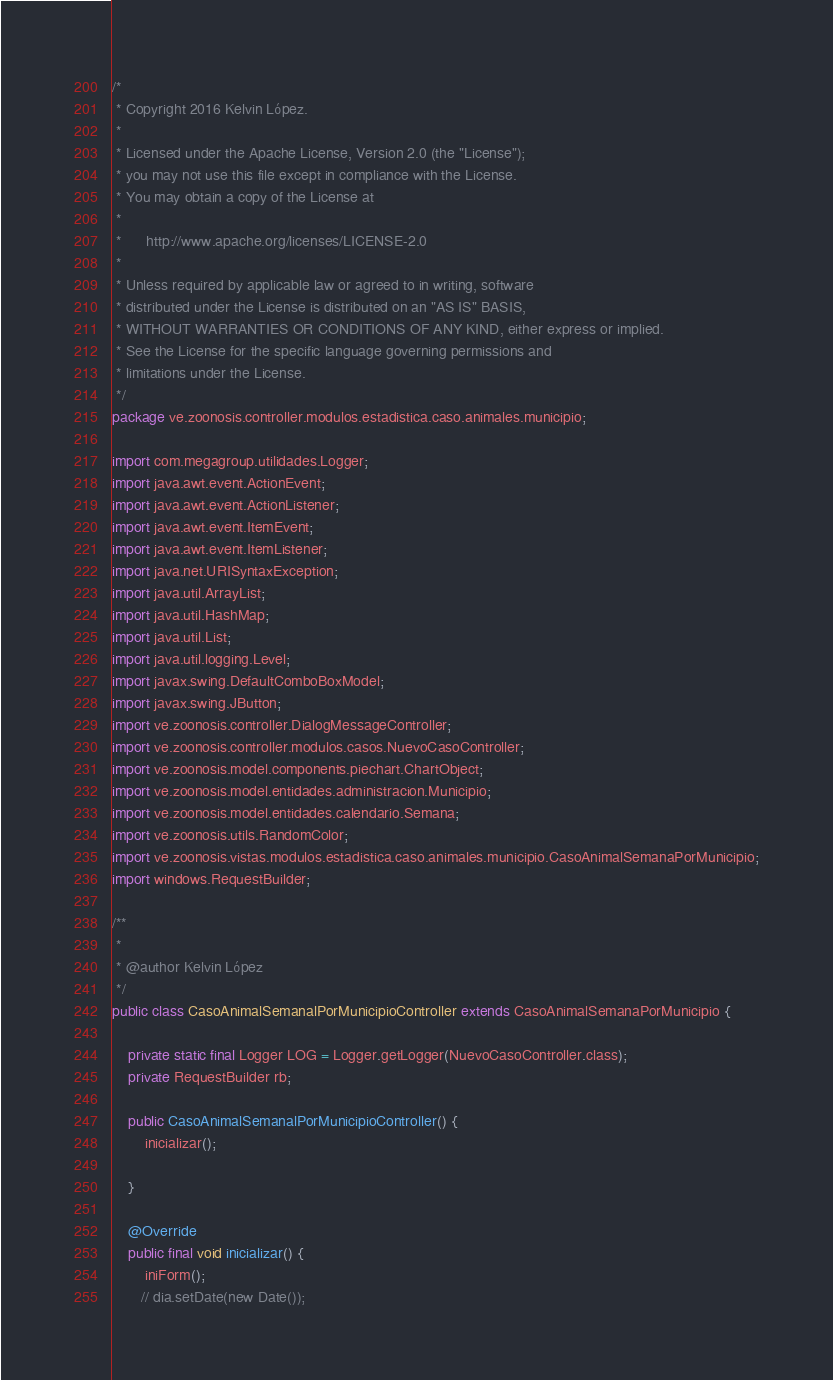<code> <loc_0><loc_0><loc_500><loc_500><_Java_>/*
 * Copyright 2016 Kelvin López.
 *
 * Licensed under the Apache License, Version 2.0 (the "License");
 * you may not use this file except in compliance with the License.
 * You may obtain a copy of the License at
 *
 *      http://www.apache.org/licenses/LICENSE-2.0
 *
 * Unless required by applicable law or agreed to in writing, software
 * distributed under the License is distributed on an "AS IS" BASIS,
 * WITHOUT WARRANTIES OR CONDITIONS OF ANY KIND, either express or implied.
 * See the License for the specific language governing permissions and
 * limitations under the License.
 */
package ve.zoonosis.controller.modulos.estadistica.caso.animales.municipio;

import com.megagroup.utilidades.Logger;
import java.awt.event.ActionEvent;
import java.awt.event.ActionListener;
import java.awt.event.ItemEvent;
import java.awt.event.ItemListener;
import java.net.URISyntaxException;
import java.util.ArrayList;
import java.util.HashMap;
import java.util.List;
import java.util.logging.Level;
import javax.swing.DefaultComboBoxModel;
import javax.swing.JButton;
import ve.zoonosis.controller.DialogMessageController;
import ve.zoonosis.controller.modulos.casos.NuevoCasoController;
import ve.zoonosis.model.components.piechart.ChartObject;
import ve.zoonosis.model.entidades.administracion.Municipio;
import ve.zoonosis.model.entidades.calendario.Semana;
import ve.zoonosis.utils.RandomColor;
import ve.zoonosis.vistas.modulos.estadistica.caso.animales.municipio.CasoAnimalSemanaPorMunicipio;
import windows.RequestBuilder;

/**
 *
 * @author Kelvin López
 */
public class CasoAnimalSemanalPorMunicipioController extends CasoAnimalSemanaPorMunicipio {

    private static final Logger LOG = Logger.getLogger(NuevoCasoController.class);
    private RequestBuilder rb;

    public CasoAnimalSemanalPorMunicipioController() {
        inicializar();

    }

    @Override
    public final void inicializar() {
        iniForm();
       // dia.setDate(new Date());</code> 